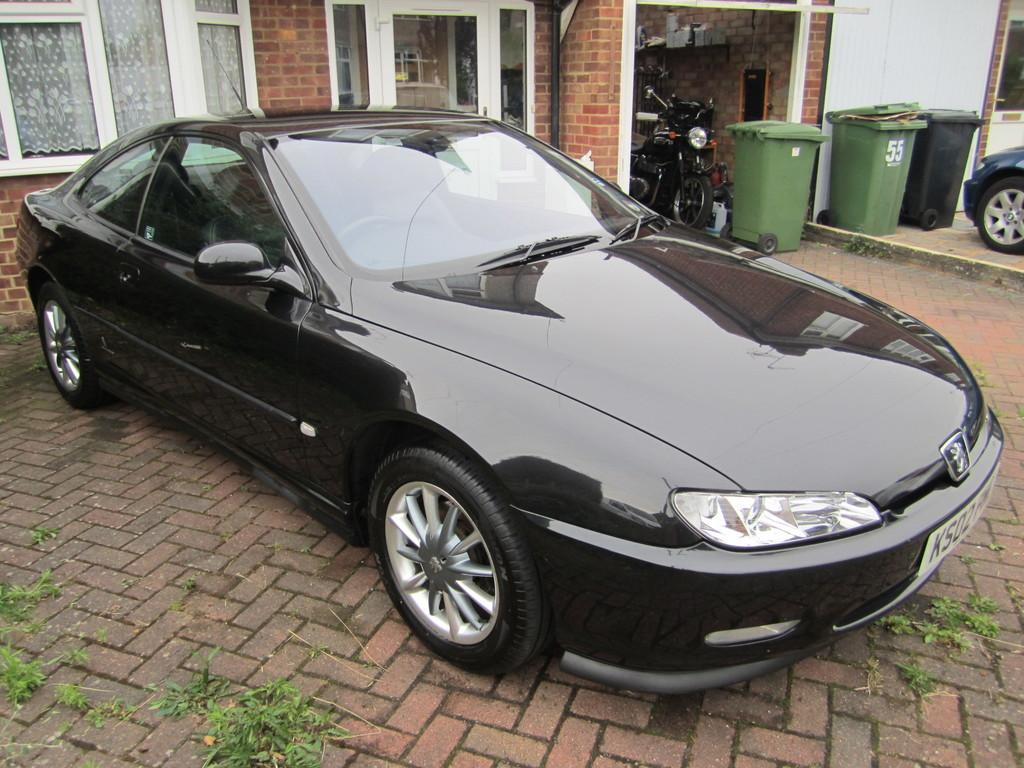What is the main subject in the middle of the image? There is a car in the middle of the image. What objects can be seen in the background of the image? There are dustbins, a bike, windows, curtains, glasses, a pipe, and a wall visible in the background of the image. What is present at the bottom of the image? There are leaves and a floor visible at the bottom of the image. What type of stove can be seen in the image? There is no stove present in the image. What thrilling activity is taking place in the image? The image does not depict any specific activity, let alone a thrilling one. 